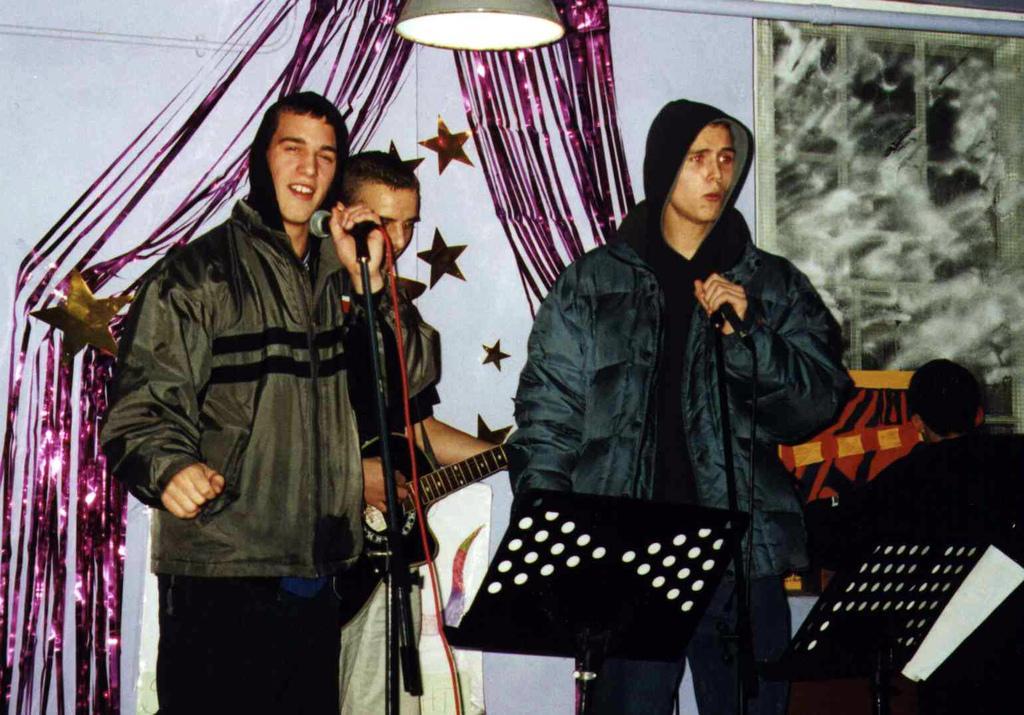Describe this image in one or two sentences. In this picture we can see some boys standing in front wearing jackets and singing on the microphone. Behind there is a boy playing the guitar. In the background there is a white wall with purple decorative ribbons.  